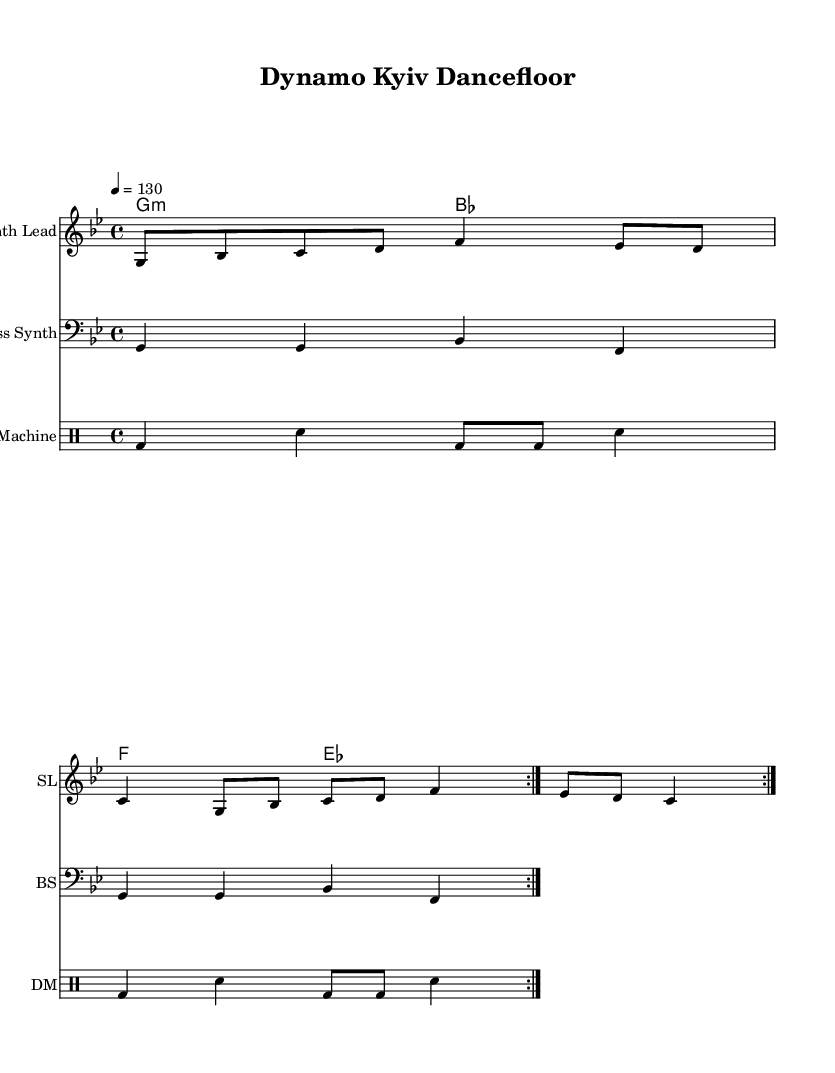What is the key signature of this music? The key signature is G minor, indicated by the one flat (B flat) symbol, which appears at the beginning of the staff.
Answer: G minor What is the time signature of this piece? The time signature is 4/4, as represented at the beginning of the score, indicating four beats per measure and a quarter note gets one beat.
Answer: 4/4 What is the tempo marking of this composition? The tempo is marked as quarter note equals 130 beats per minute, indicated by "4 = 130" at the beginning of the score, specifying how fast the piece should be played.
Answer: 130 How many times does the synth lead repeat? The synth lead part has a repeat sign that indicates playing the section two times, denoted by the "volta" marking in the score.
Answer: 2 What instrument plays the bass synth part? The bass synth part is specified under the heading "Bass Synth" and is written on a staff with the bass clef, indicating that it is a lower-range synthesizer sound.
Answer: Bass Synth What is the primary rhythmic element in the drum pattern? The primary rhythmic element includes bass drum (bd) and snare (sn) hits, with a repeated pattern indicating a consistent techno rhythm typical for dance music.
Answer: Bass drum and snare What chord is played in the first measure? The chord in the first measure is G minor, which is derived from the chord names written above the synth lead part and indicated by the chord symbols.
Answer: G minor 